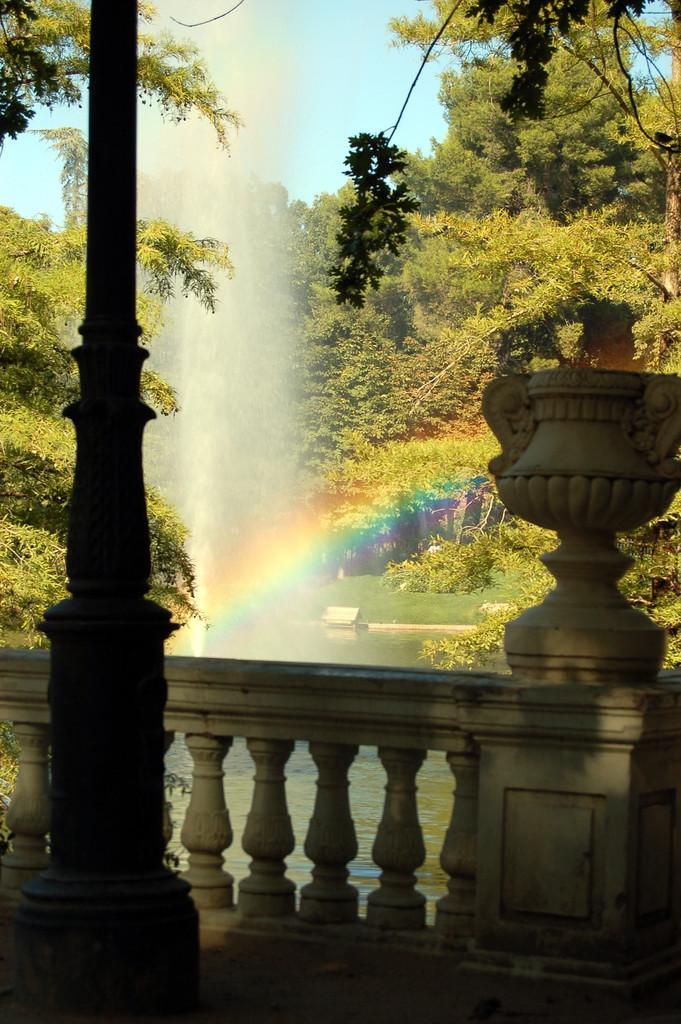In one or two sentences, can you explain what this image depicts? Here in this picture, on the left side we can see a pole present and in front of it we can see a railing present and we can also see water present all over there and we can also see a rainbow present and we can see a water fountain present and we can see some part of ground is covered with grass and we can see plants and trees present and we can see the sky is clear. 